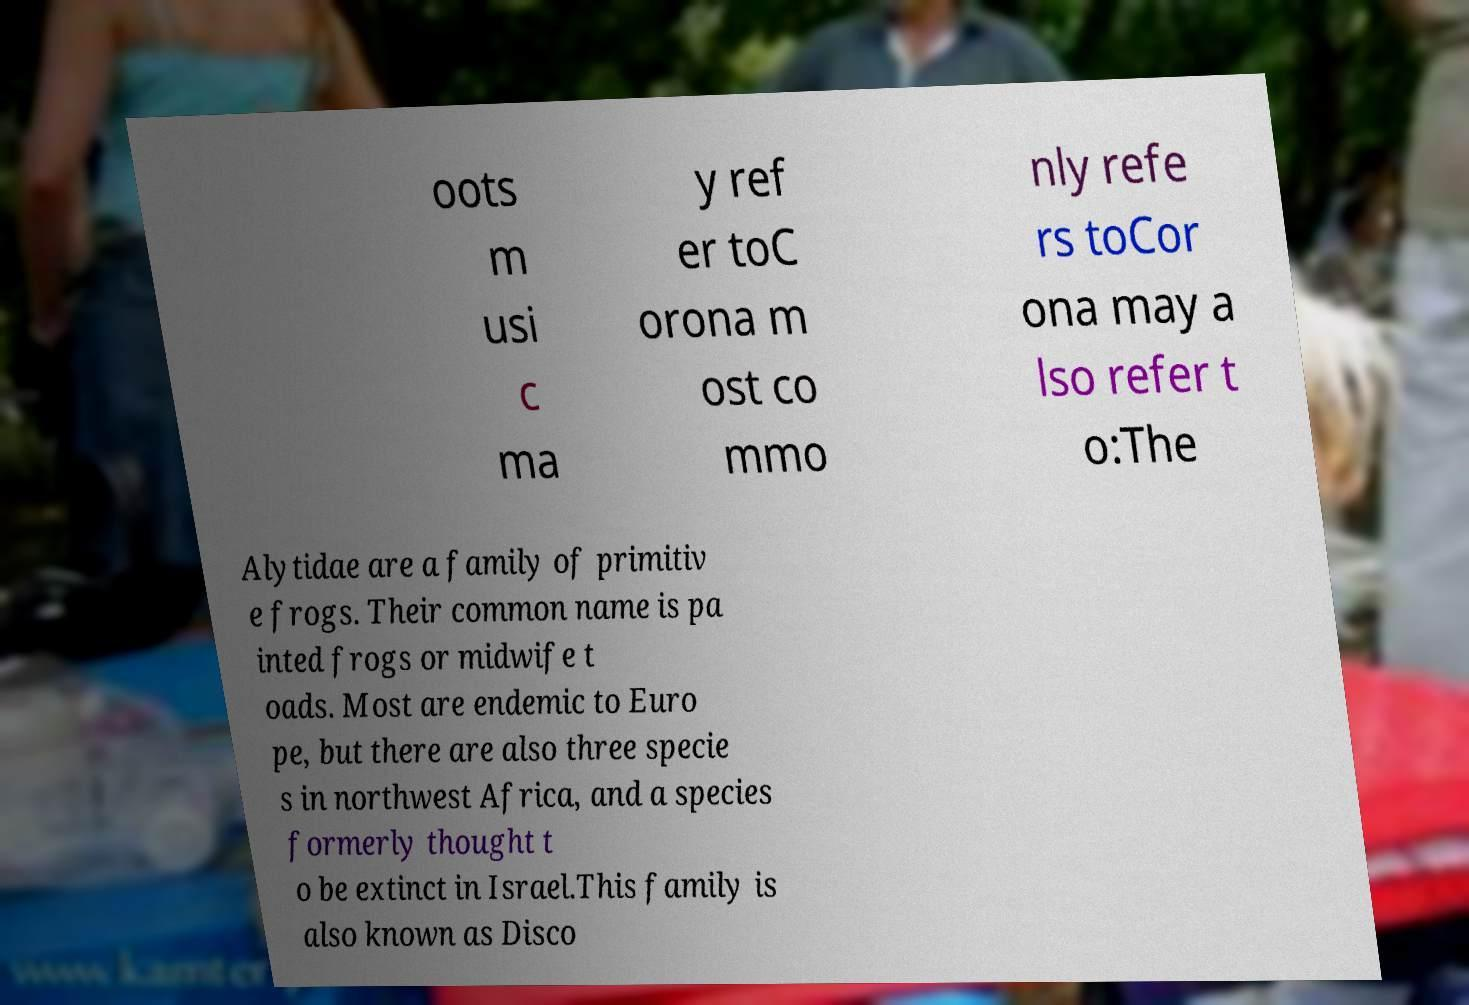I need the written content from this picture converted into text. Can you do that? oots m usi c ma y ref er toC orona m ost co mmo nly refe rs toCor ona may a lso refer t o:The Alytidae are a family of primitiv e frogs. Their common name is pa inted frogs or midwife t oads. Most are endemic to Euro pe, but there are also three specie s in northwest Africa, and a species formerly thought t o be extinct in Israel.This family is also known as Disco 